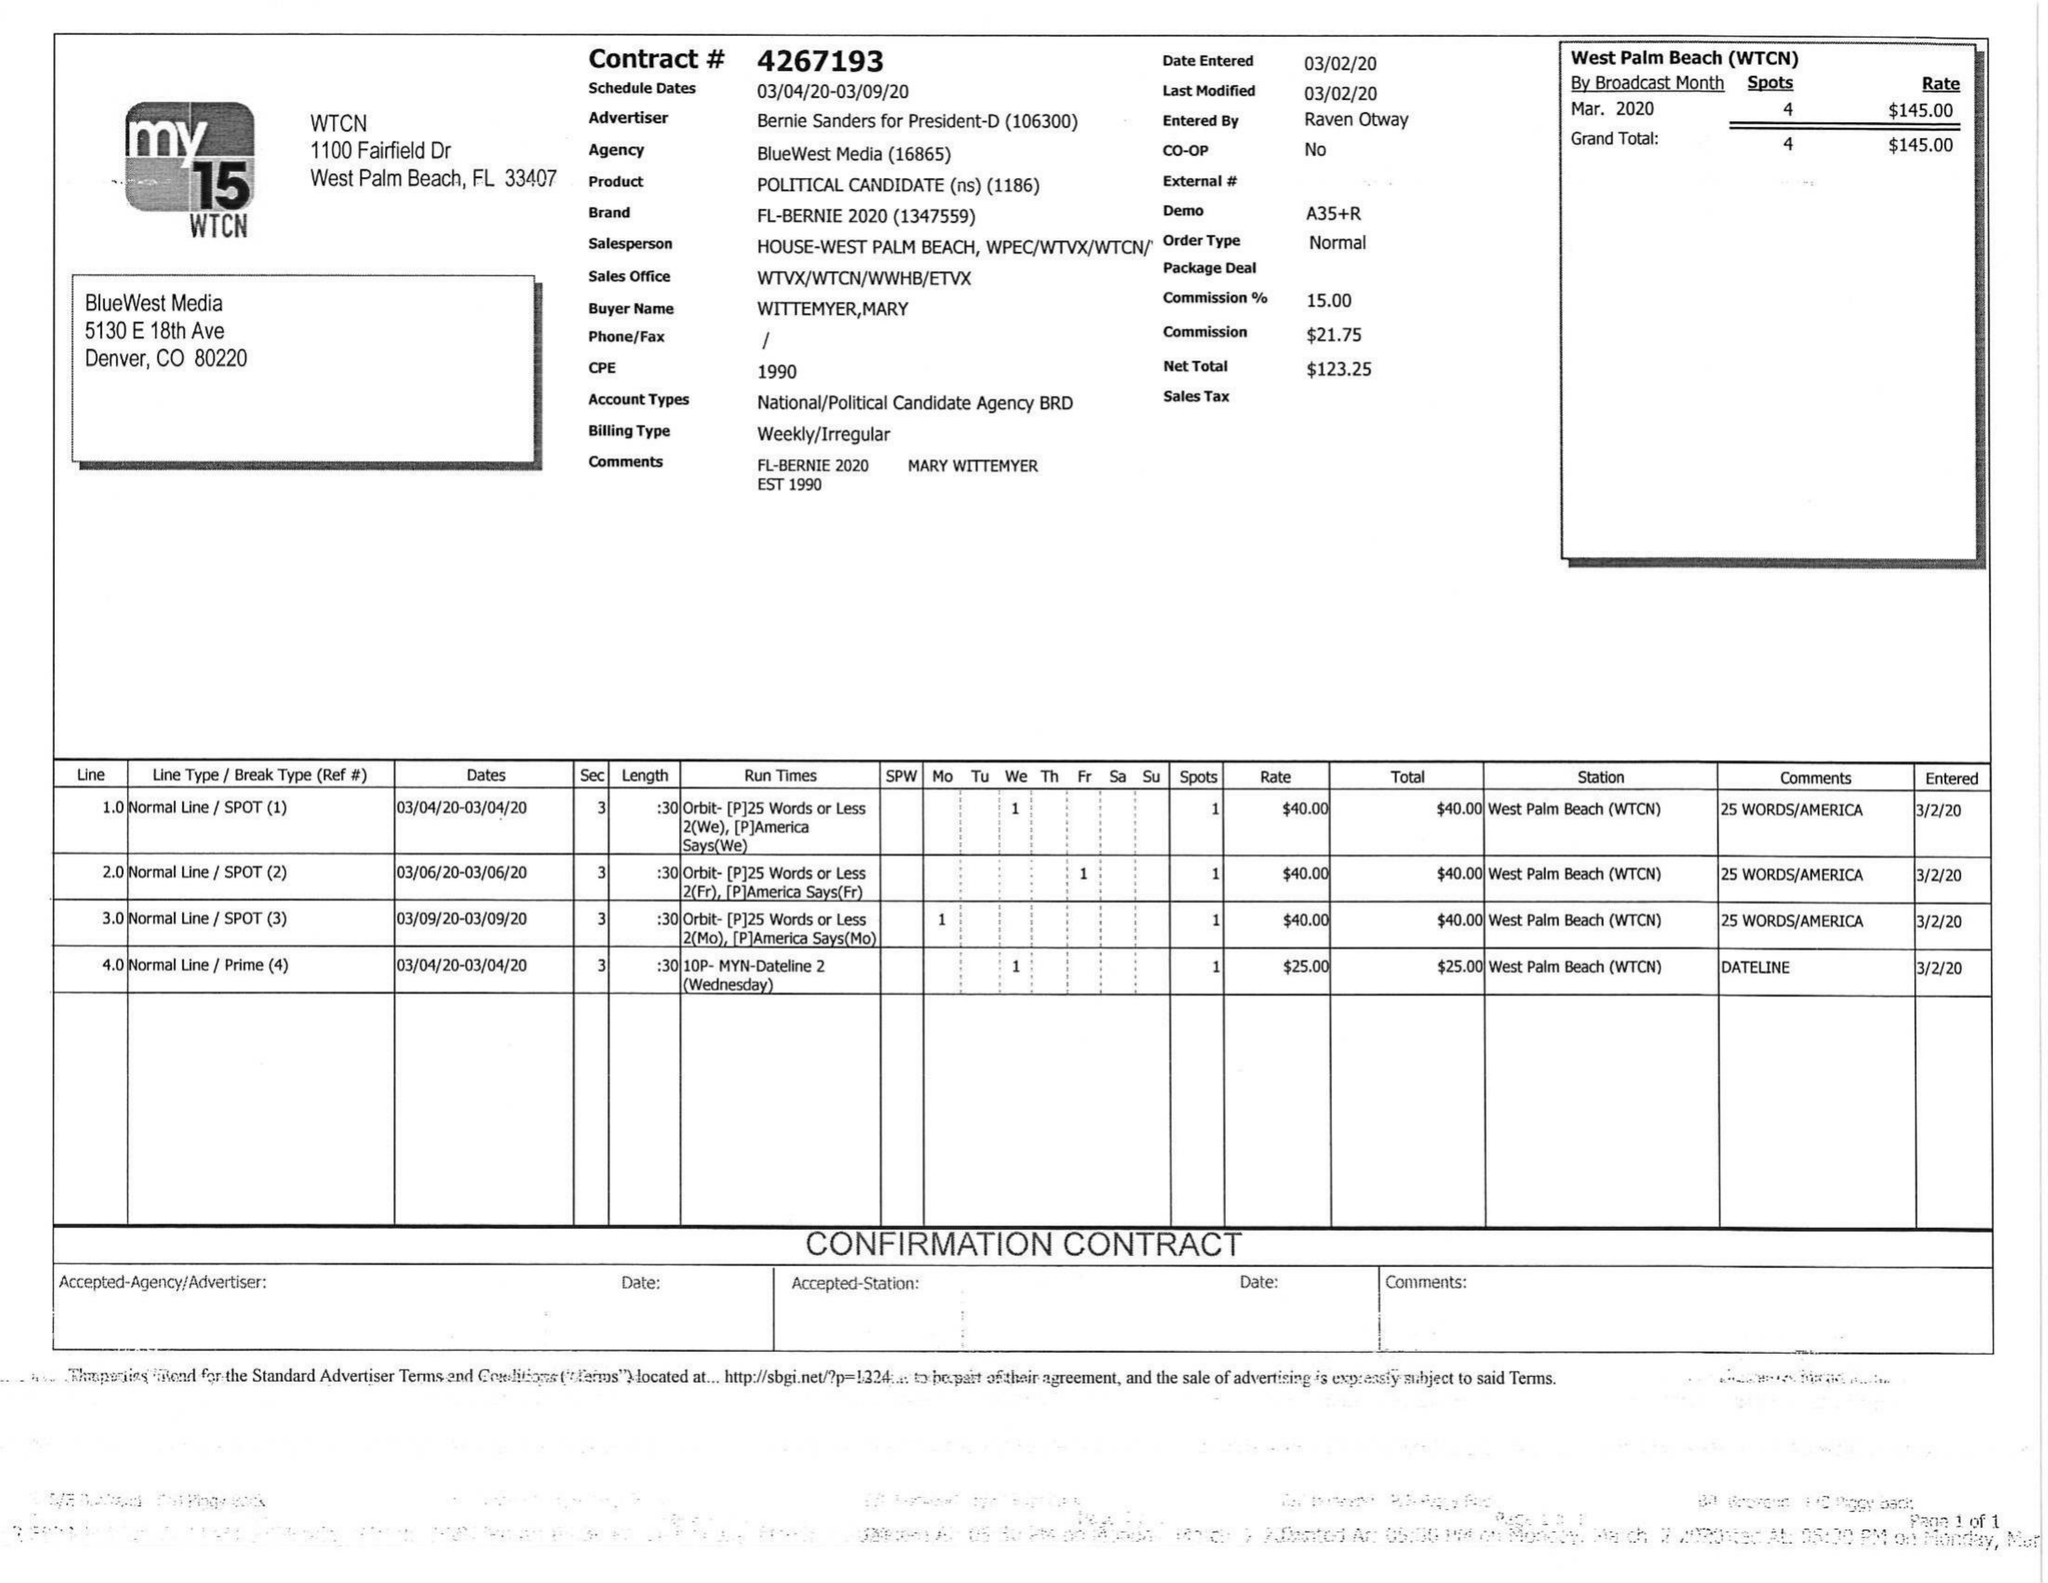What is the value for the advertiser?
Answer the question using a single word or phrase. BERNIE SANDERS FOR PRESIDENT-D 